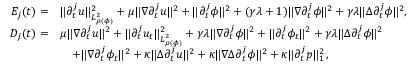Convert formula to latex. <formula><loc_0><loc_0><loc_500><loc_500>\begin{array} { r l } { { E } _ { j } ( t ) = } & { \| \partial _ { t } ^ { j } u \| _ { L _ { \rho ( \phi ) } ^ { 2 } } ^ { 2 } + \mu \| \nabla \partial _ { t } ^ { j } u \| ^ { 2 } + \| \partial _ { t } ^ { j } \phi \| ^ { 2 } + ( \gamma \lambda + 1 ) \| \nabla \partial _ { t } ^ { j } \phi \| ^ { 2 } + \gamma \lambda \| \Delta \partial _ { t } ^ { j } \phi \| ^ { 2 } , } \\ { { D } _ { j } ( t ) = } & { \mu \| \nabla \partial _ { t } ^ { j } u \| ^ { 2 } + \| \partial _ { t } ^ { j } u _ { t } \| _ { L _ { \rho ( \phi ) } ^ { 2 } } ^ { 2 } + \gamma \lambda \| \nabla \partial _ { t } ^ { j } \phi \| ^ { 2 } + \| \partial _ { t } ^ { j } \phi _ { t } \| ^ { 2 } + \gamma \lambda \| \Delta \partial _ { t } ^ { j } \phi \| ^ { 2 } } \\ & { \quad + \| \nabla \partial _ { t } ^ { j } \phi _ { t } \| ^ { 2 } + \kappa \| \Delta \partial _ { t } ^ { j } u \| ^ { 2 } + \kappa \| \nabla \Delta \partial _ { t } ^ { j } \phi \| ^ { 2 } + \kappa \| \partial _ { t } ^ { j } p \| _ { 1 } ^ { 2 } \, , } \end{array}</formula> 